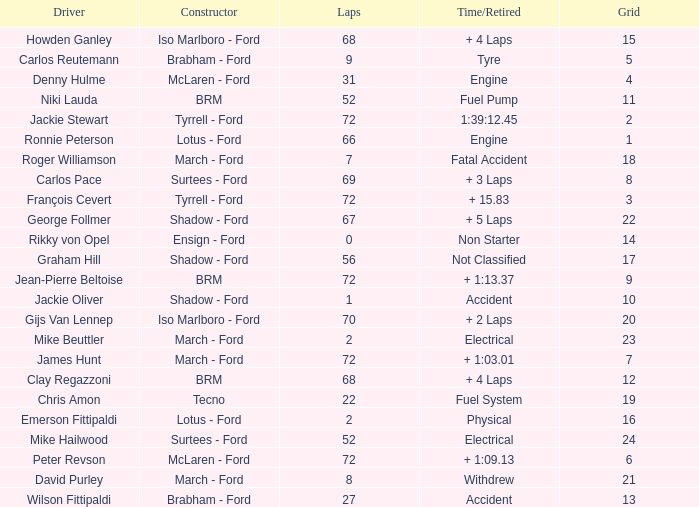What is the top grid that roger williamson lapped less than 7? None. 